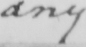What text is written in this handwritten line? any 